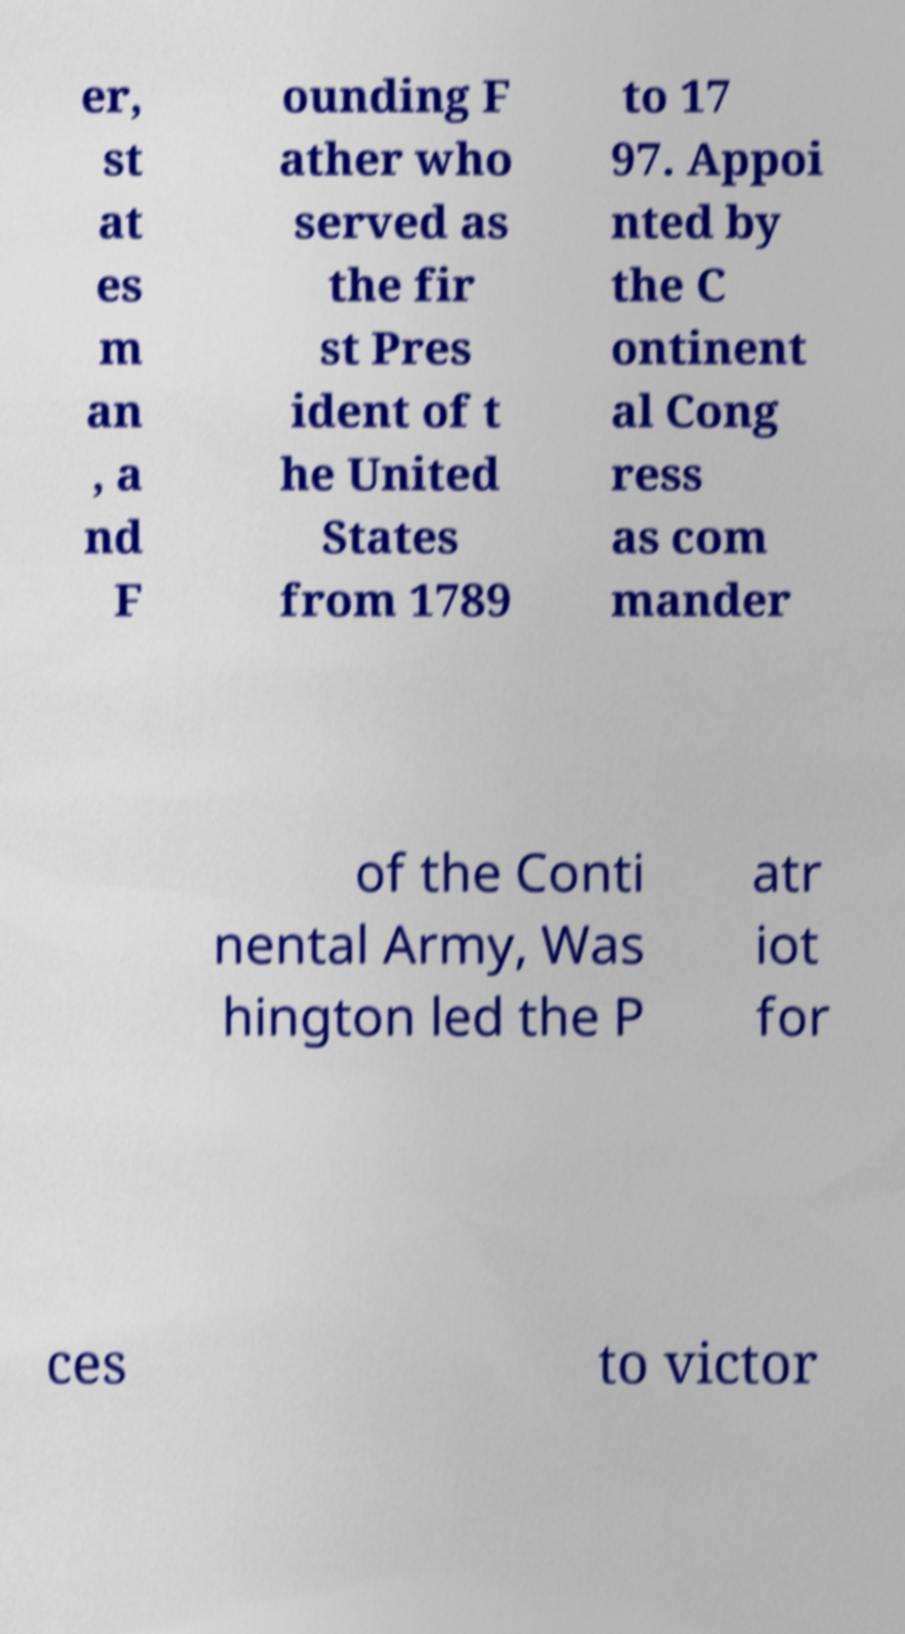Please identify and transcribe the text found in this image. er, st at es m an , a nd F ounding F ather who served as the fir st Pres ident of t he United States from 1789 to 17 97. Appoi nted by the C ontinent al Cong ress as com mander of the Conti nental Army, Was hington led the P atr iot for ces to victor 